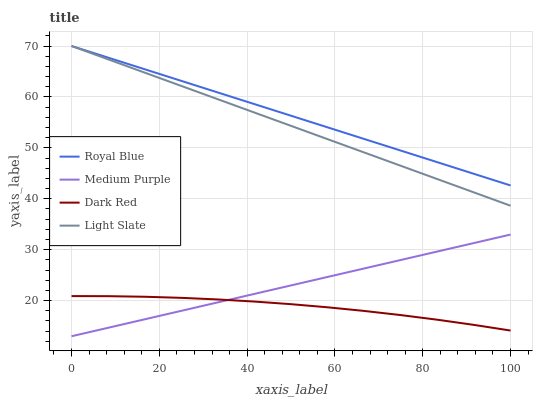Does Light Slate have the minimum area under the curve?
Answer yes or no. No. Does Light Slate have the maximum area under the curve?
Answer yes or no. No. Is Royal Blue the smoothest?
Answer yes or no. No. Is Royal Blue the roughest?
Answer yes or no. No. Does Light Slate have the lowest value?
Answer yes or no. No. Does Dark Red have the highest value?
Answer yes or no. No. Is Medium Purple less than Royal Blue?
Answer yes or no. Yes. Is Royal Blue greater than Dark Red?
Answer yes or no. Yes. Does Medium Purple intersect Royal Blue?
Answer yes or no. No. 